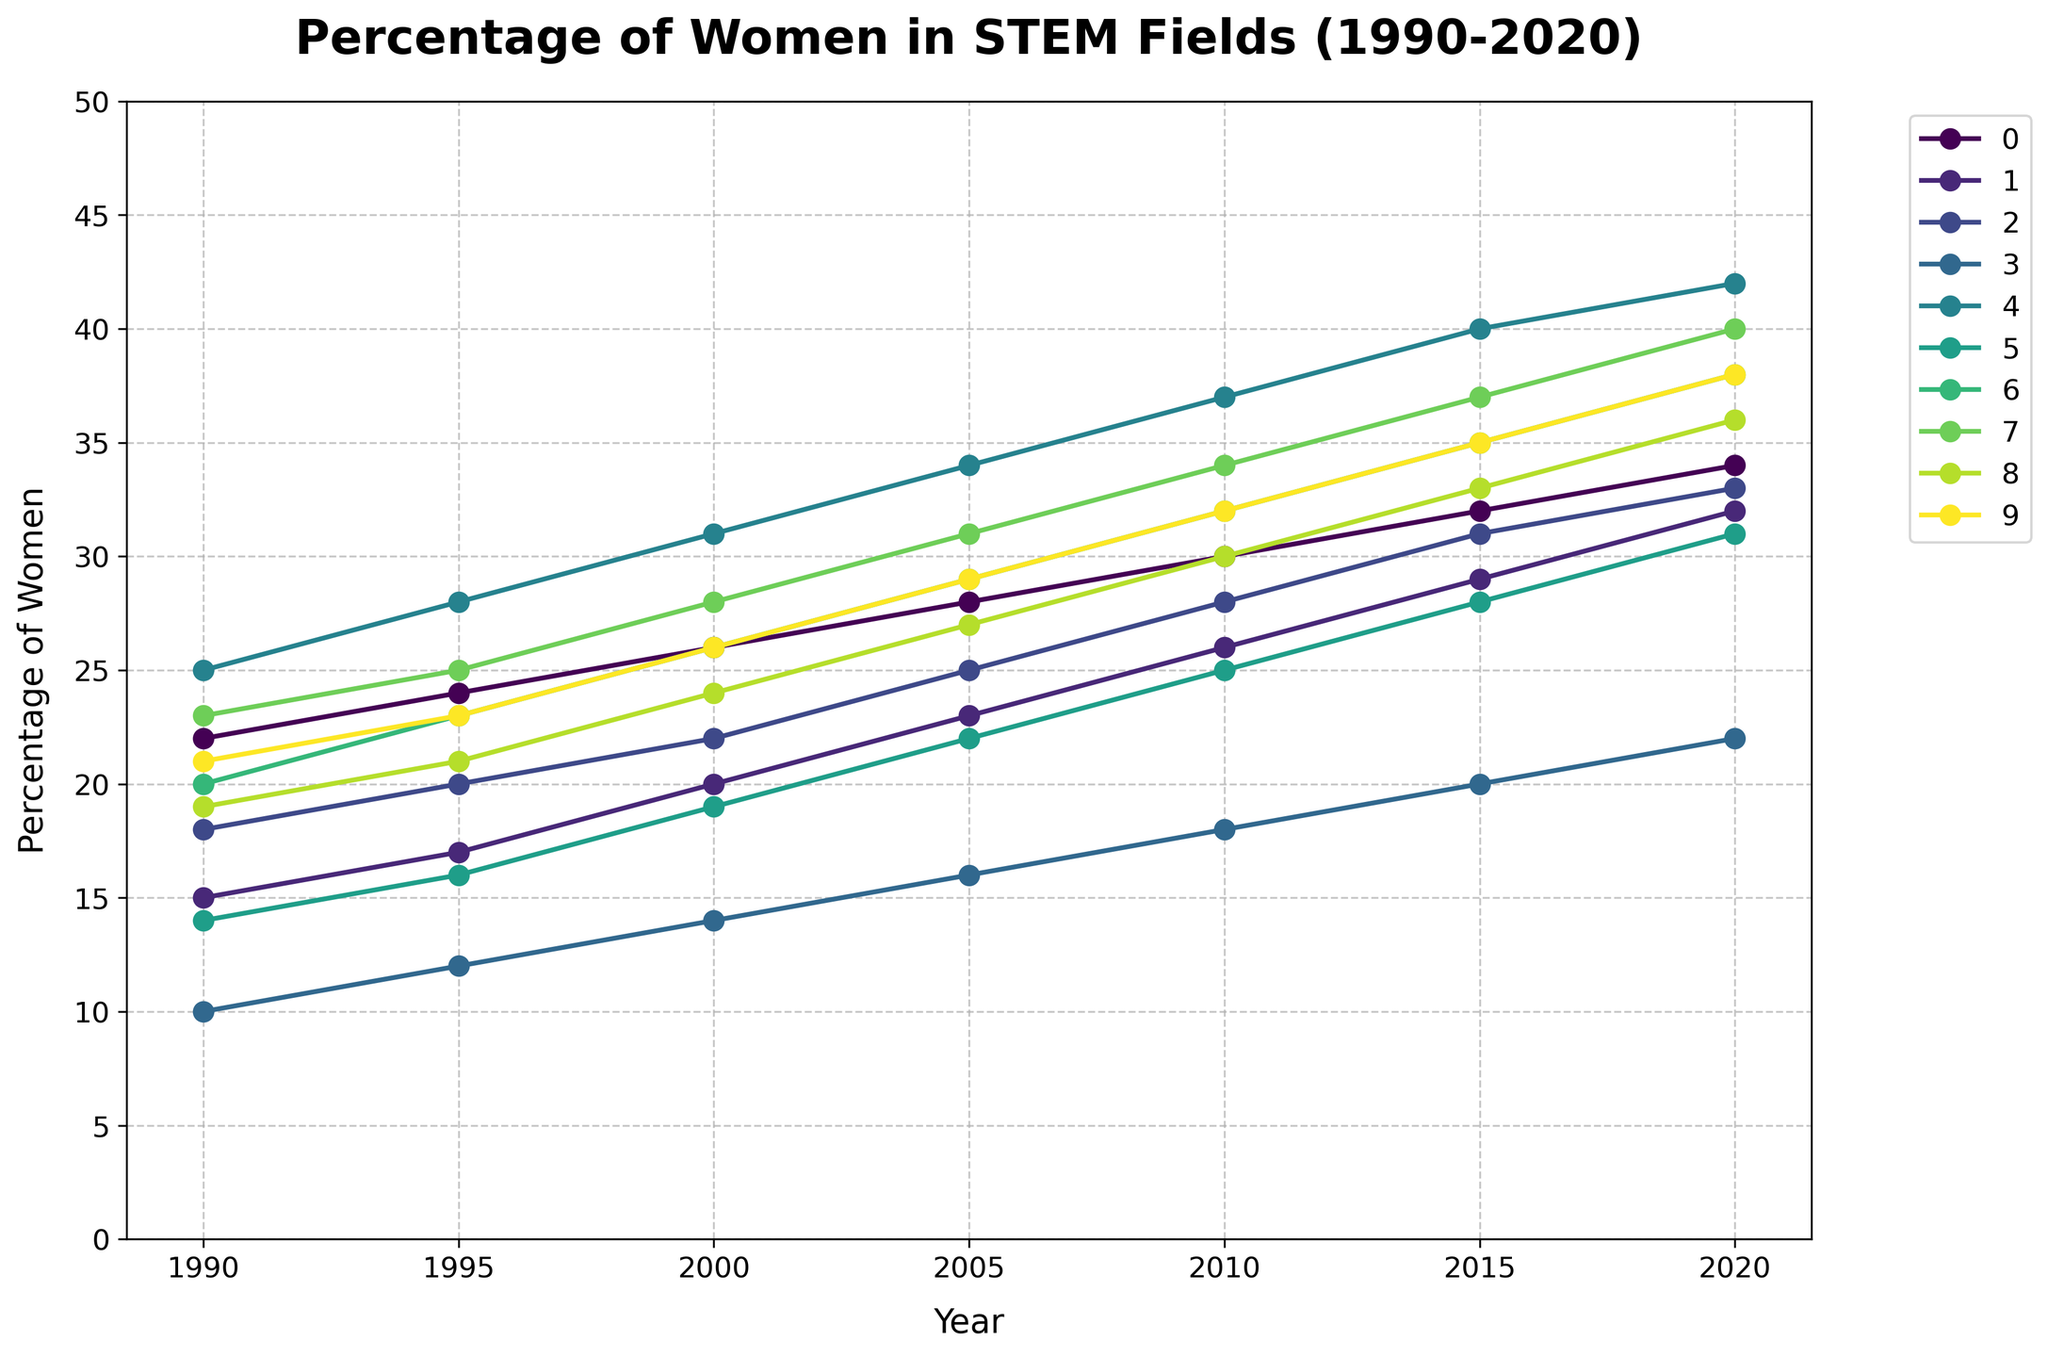Which country shows the highest percentage of women in STEM fields by 2020? Look at the rightmost end of the lines on the figure; the highest line corresponds to Sweden.
Answer: Sweden What was the percentage of women in STEM fields in Japan in 2000? Trace the line representing Japan to the point corresponding to the year 2000; the value is 14.
Answer: 14 Between 1990 and 2020, which country experienced the largest increase in the percentage of women in STEM fields? Compare the difference between the 2020 and 1990 values for each country; Brazil went from 23% to 40%, an increase of 17 percentage points, the greatest among all countries.
Answer: Brazil How did the percentage of women in STEM in India change from 1990 to 2020? Look at the start and end points of the line representing India; the percentage increased from 14% to 31%.
Answer: It increased by 17% Which countries had more than 30% women in STEM fields by 2015? Identify lines reaching above the 30% mark by the year 2015; China, Brazil, Sweden, and Germany all pass this threshold.
Answer: China, Brazil, Sweden, and Germany What is the average percentage of women in STEM fields in the United States across all the recorded years? Add the percentage values for each year (22 + 24 + 26 + 28 + 30 + 32 + 34) and divide by the number of years (7); the calculation is 196 / 7 = 28.
Answer: 28 Which two countries had the closest percentage of women in STEM fields in 2010? Compare the values in 2010 for each country; the United States and China both had 30%, making them closest.
Answer: United States and China What was the range of percentages for women in STEM fields in 1995 across all countries? The range is calculated by subtracting the lowest percentage (Japan at 12%) from the highest (Sweden at 28%); the range is 28 - 12 = 16.
Answer: 16 How many countries had a percentage increase of at least 15% from 1990 to 2020? Calculate the increase for each country, and count those with an increase of 15% or more: Sweden (17%), Brazil (17%), China (18%), and South Africa (17%).
Answer: 4 By how many percentage points did the percentage of women in STEM fields in Germany increase between 2000 and 2015? Subtract the 2000 value from the 2015 value for Germany: 31% - 22% = 9%.
Answer: 9 